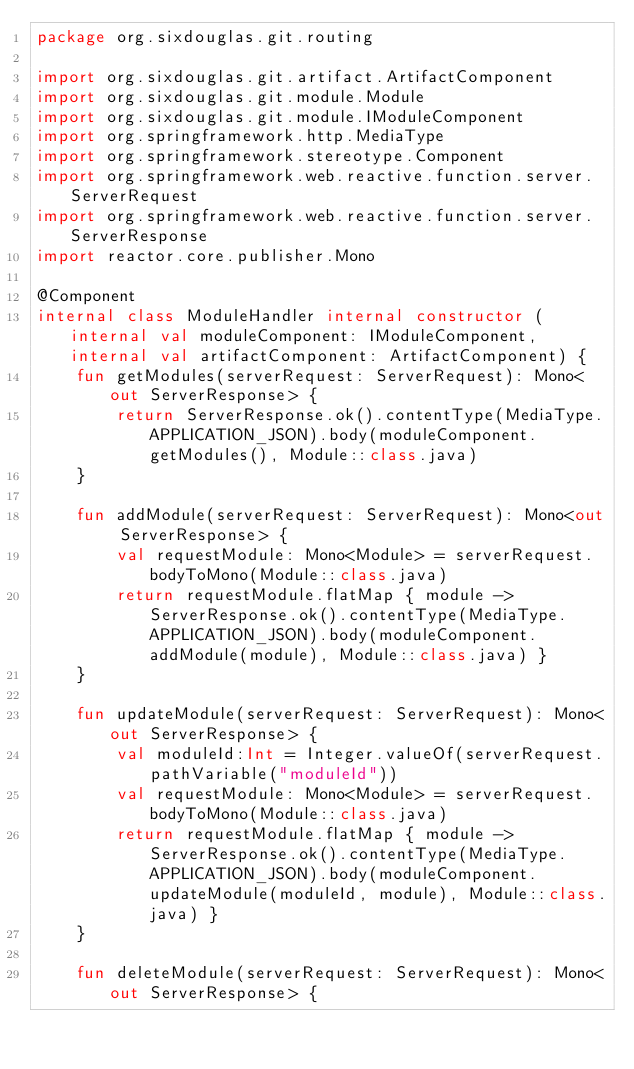Convert code to text. <code><loc_0><loc_0><loc_500><loc_500><_Kotlin_>package org.sixdouglas.git.routing

import org.sixdouglas.git.artifact.ArtifactComponent
import org.sixdouglas.git.module.Module
import org.sixdouglas.git.module.IModuleComponent
import org.springframework.http.MediaType
import org.springframework.stereotype.Component
import org.springframework.web.reactive.function.server.ServerRequest
import org.springframework.web.reactive.function.server.ServerResponse
import reactor.core.publisher.Mono

@Component
internal class ModuleHandler internal constructor (internal val moduleComponent: IModuleComponent,internal val artifactComponent: ArtifactComponent) {
    fun getModules(serverRequest: ServerRequest): Mono<out ServerResponse> {
        return ServerResponse.ok().contentType(MediaType.APPLICATION_JSON).body(moduleComponent.getModules(), Module::class.java)
    }

    fun addModule(serverRequest: ServerRequest): Mono<out ServerResponse> {
        val requestModule: Mono<Module> = serverRequest.bodyToMono(Module::class.java)
        return requestModule.flatMap { module ->  ServerResponse.ok().contentType(MediaType.APPLICATION_JSON).body(moduleComponent.addModule(module), Module::class.java) }
    }

    fun updateModule(serverRequest: ServerRequest): Mono<out ServerResponse> {
        val moduleId:Int = Integer.valueOf(serverRequest.pathVariable("moduleId"))
        val requestModule: Mono<Module> = serverRequest.bodyToMono(Module::class.java)
        return requestModule.flatMap { module -> ServerResponse.ok().contentType(MediaType.APPLICATION_JSON).body(moduleComponent.updateModule(moduleId, module), Module::class.java) }
    }

    fun deleteModule(serverRequest: ServerRequest): Mono<out ServerResponse> {</code> 